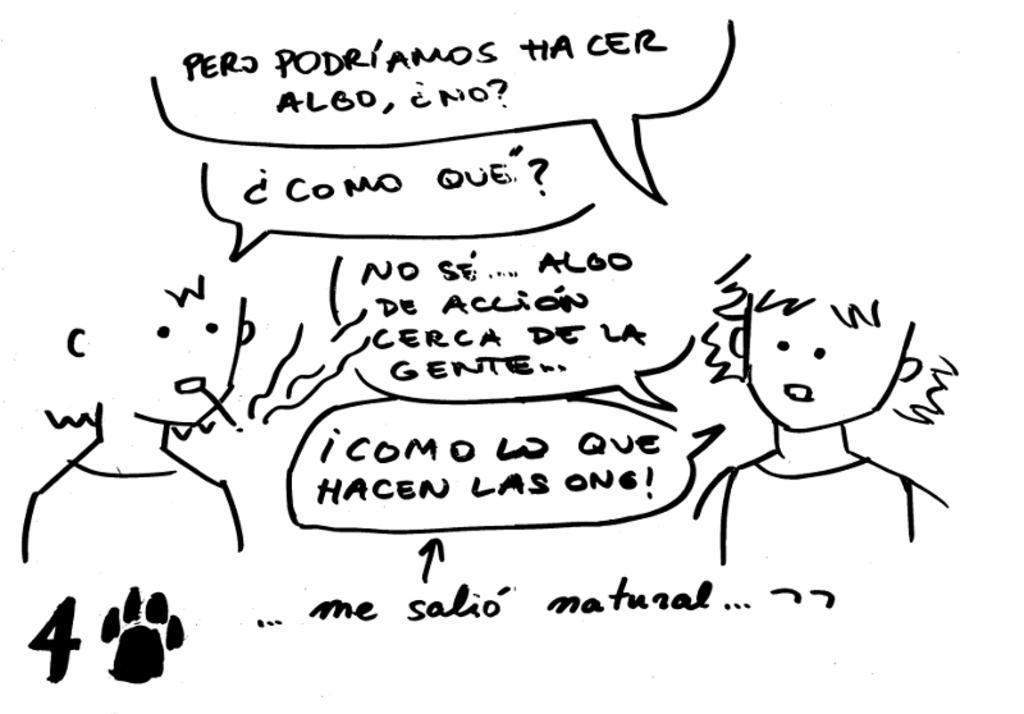Describe this image in one or two sentences. In this image I can see the sketch of two persons and some text. The background is in white color. 